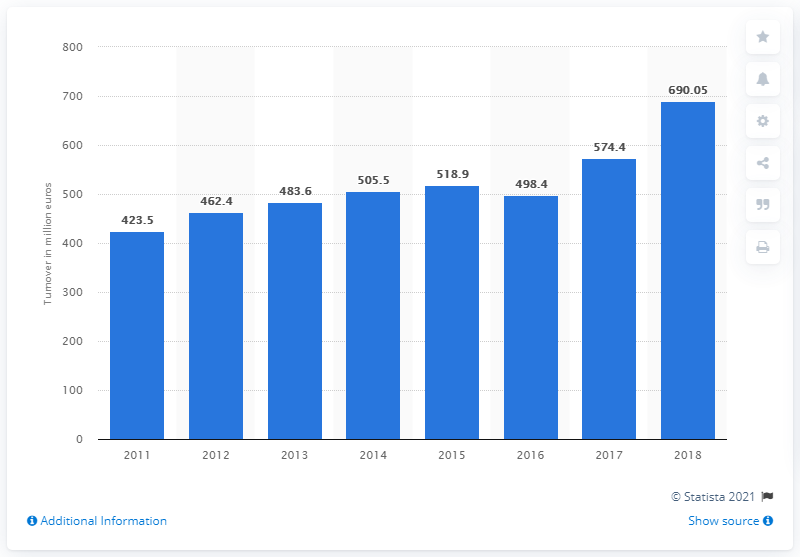Specify some key components in this picture. Loro Piana S.p.A. reported a turnover of 423.5.. in 2011. In 2018, Loro Piana's annual turnover was 690.05 million. Loro Piana S.p.A. reported a turnover of 574.4 million euros in 2018. 